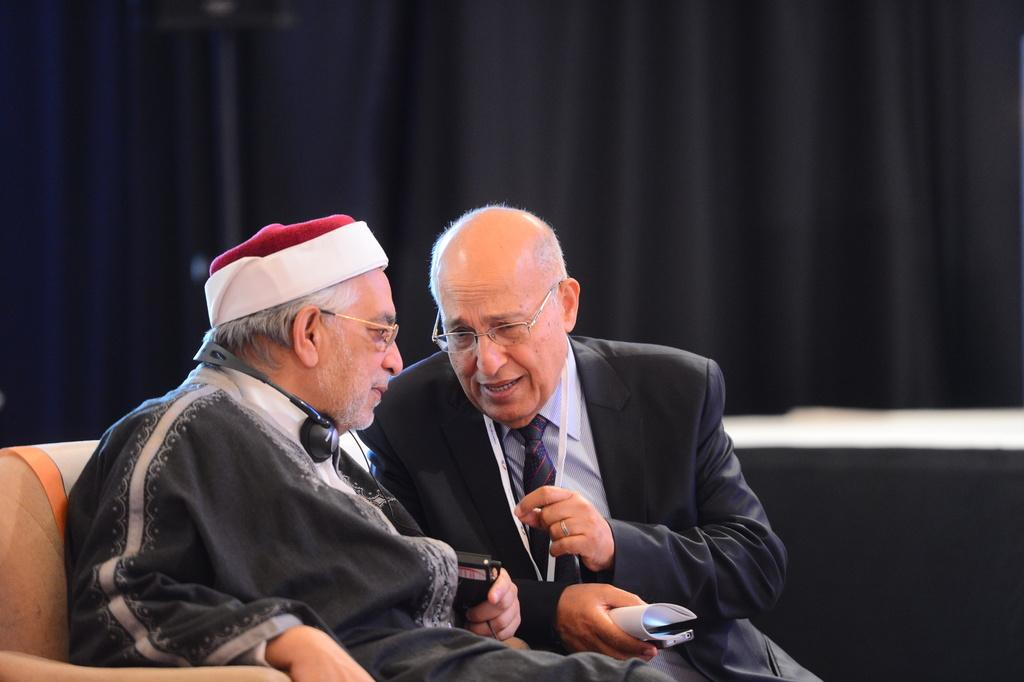How many people are in the image? There are two men in the image. What are the men doing in the image? The men are sitting in the center of the image. What can be seen in the background of the image? There is a black color curtain in the background of the image. Can you see a mountain in the background of the image? No, there is no mountain visible in the image. The background only shows a black curtain. 